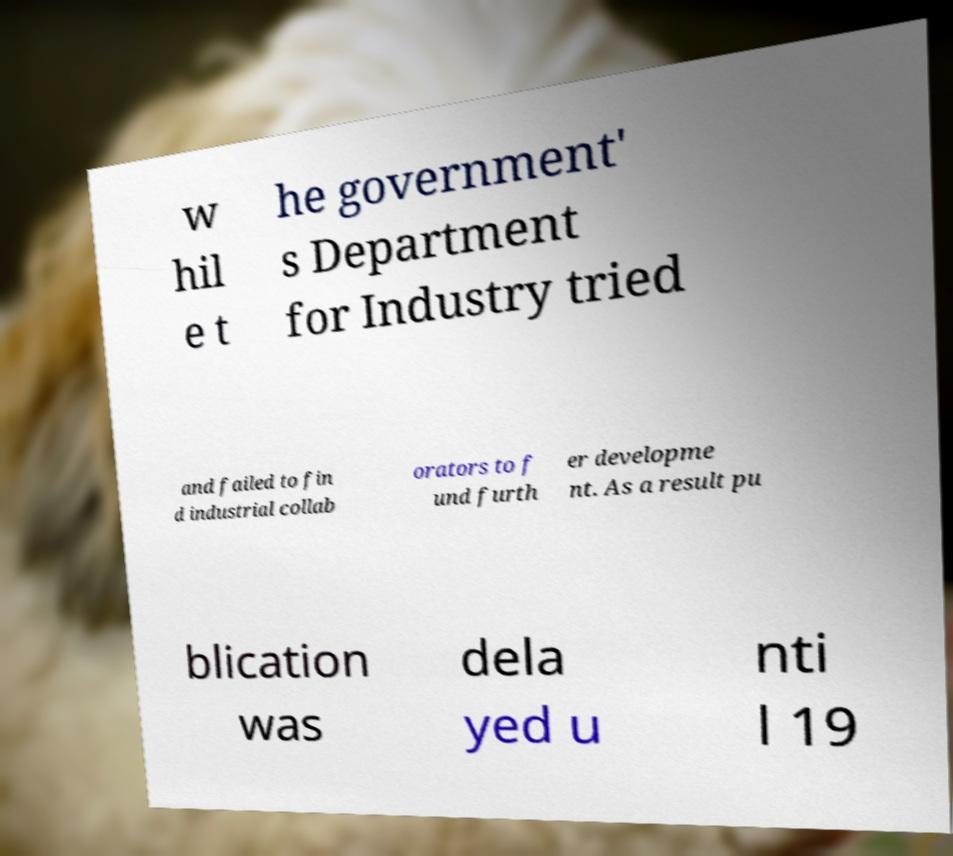For documentation purposes, I need the text within this image transcribed. Could you provide that? w hil e t he government' s Department for Industry tried and failed to fin d industrial collab orators to f und furth er developme nt. As a result pu blication was dela yed u nti l 19 